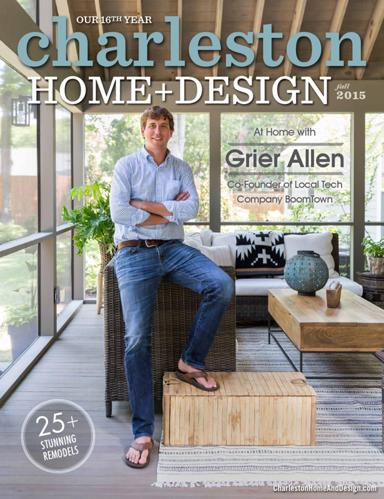Who is featured in the 2015 edition of Charleston Home Design? The 2015 edition of Charleston Home Design features Grier Allen, the co-founder of Boomtown, a prominent local tech company. The feature provides a glimpse into his tastefully decorated home that reflects a blend of modern and classic design elements. 